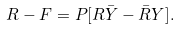<formula> <loc_0><loc_0><loc_500><loc_500>R - F = P [ R \bar { Y } - \bar { R } Y ] .</formula> 